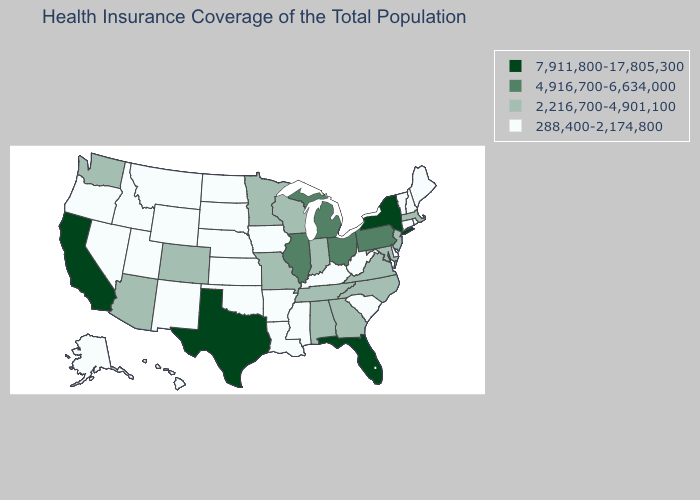Does the first symbol in the legend represent the smallest category?
Short answer required. No. Does Utah have the lowest value in the USA?
Answer briefly. Yes. Does Maine have the lowest value in the USA?
Short answer required. Yes. What is the value of Tennessee?
Quick response, please. 2,216,700-4,901,100. What is the highest value in states that border New Hampshire?
Give a very brief answer. 2,216,700-4,901,100. How many symbols are there in the legend?
Give a very brief answer. 4. Among the states that border Wyoming , which have the lowest value?
Concise answer only. Idaho, Montana, Nebraska, South Dakota, Utah. What is the highest value in the MidWest ?
Give a very brief answer. 4,916,700-6,634,000. Does the map have missing data?
Short answer required. No. What is the highest value in the USA?
Short answer required. 7,911,800-17,805,300. Name the states that have a value in the range 2,216,700-4,901,100?
Quick response, please. Alabama, Arizona, Colorado, Georgia, Indiana, Maryland, Massachusetts, Minnesota, Missouri, New Jersey, North Carolina, Tennessee, Virginia, Washington, Wisconsin. Does Kentucky have the same value as Michigan?
Short answer required. No. Name the states that have a value in the range 7,911,800-17,805,300?
Write a very short answer. California, Florida, New York, Texas. What is the value of California?
Be succinct. 7,911,800-17,805,300. Does the map have missing data?
Keep it brief. No. 